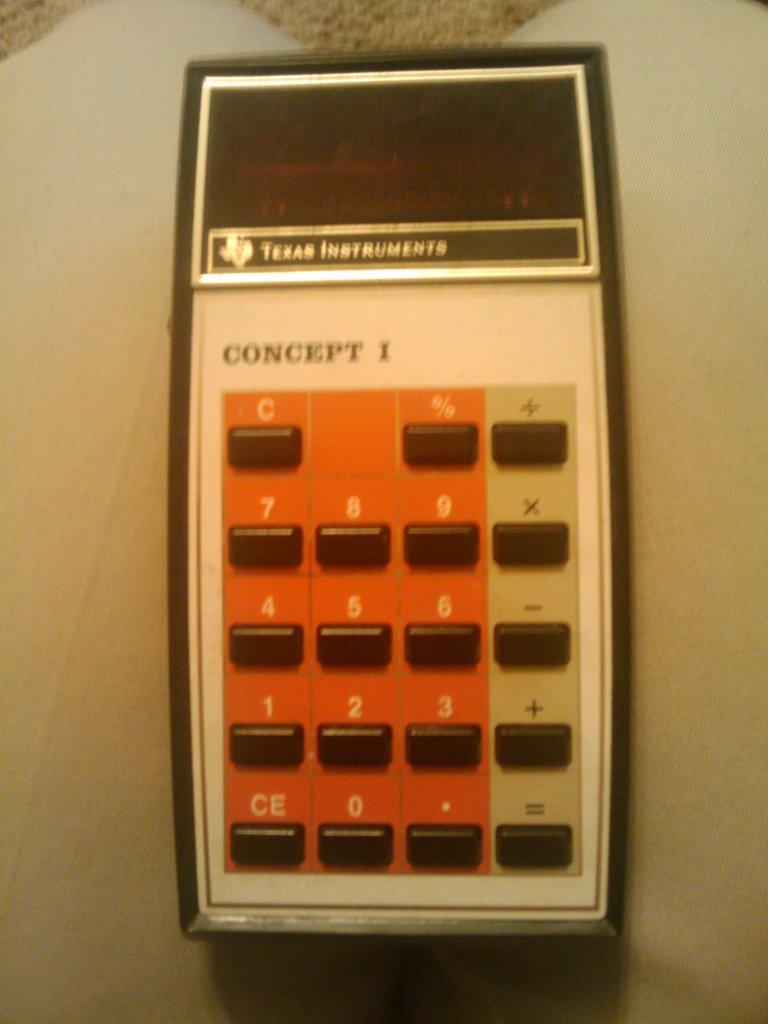<image>
Provide a brief description of the given image. An older model of a Texas Instrument Concept 1 calculator. 